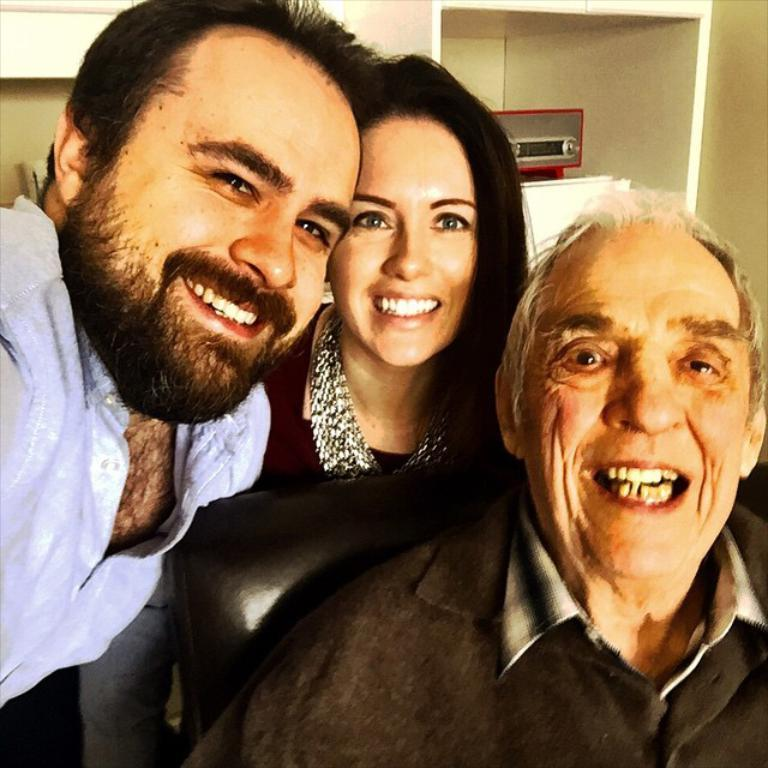Who or what can be seen in the image? There are people in the image. Can you describe the object on the right side of the image? Unfortunately, the provided facts do not give any information about the object on the right side of the image. What type of dinosaurs can be seen interacting with the people in the image? There are no dinosaurs present in the image; it only features people. 